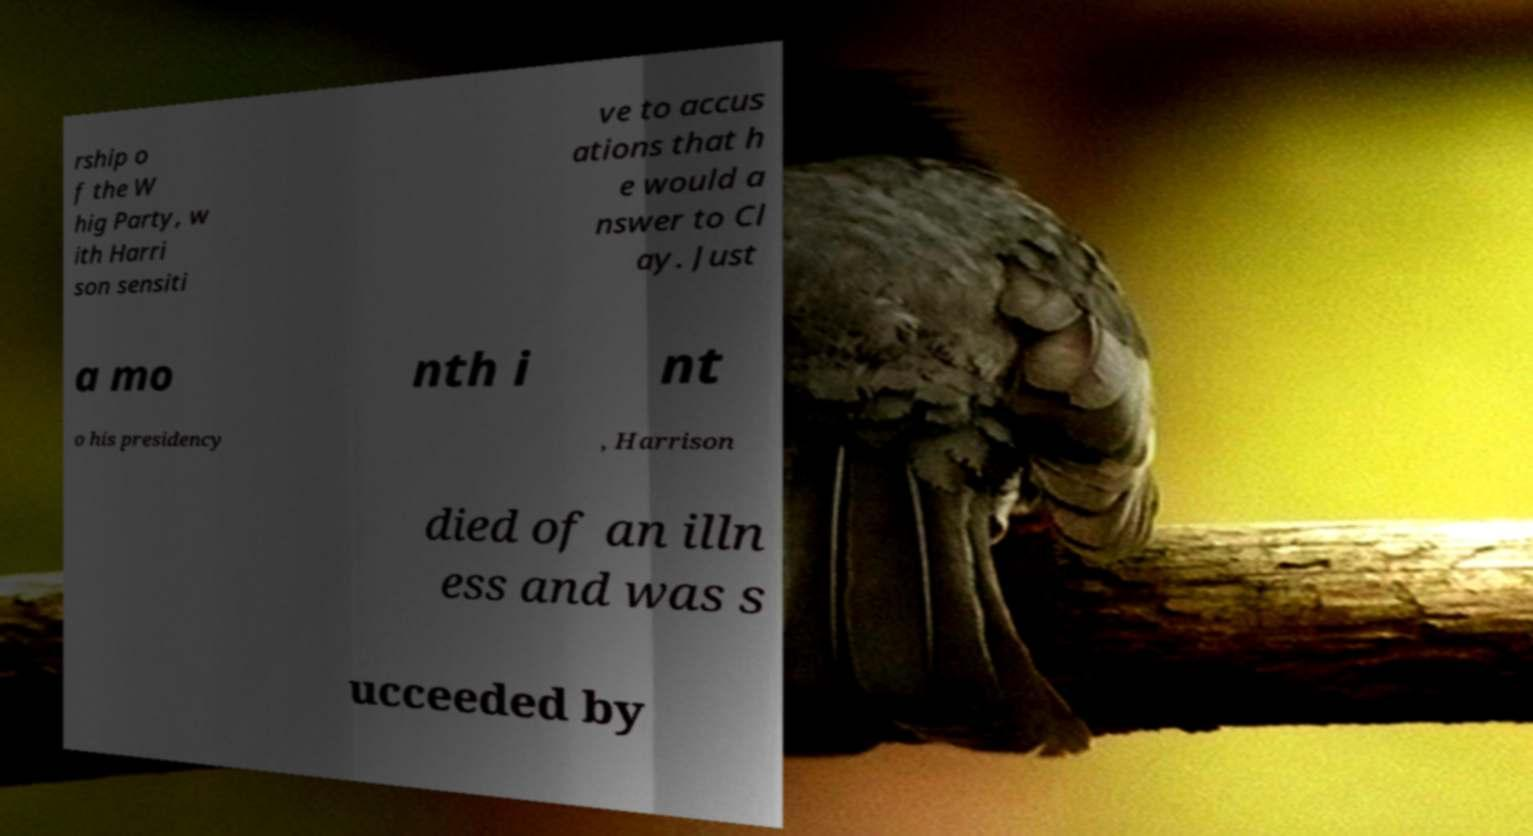Please identify and transcribe the text found in this image. rship o f the W hig Party, w ith Harri son sensiti ve to accus ations that h e would a nswer to Cl ay. Just a mo nth i nt o his presidency , Harrison died of an illn ess and was s ucceeded by 